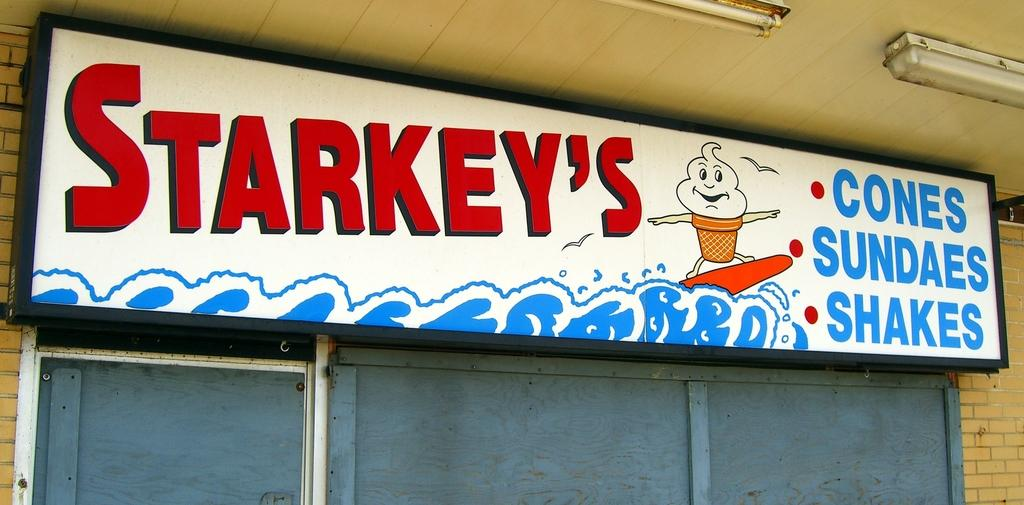<image>
Give a short and clear explanation of the subsequent image. Starkey's sells ice cream cones, sundaes, and shakes. 